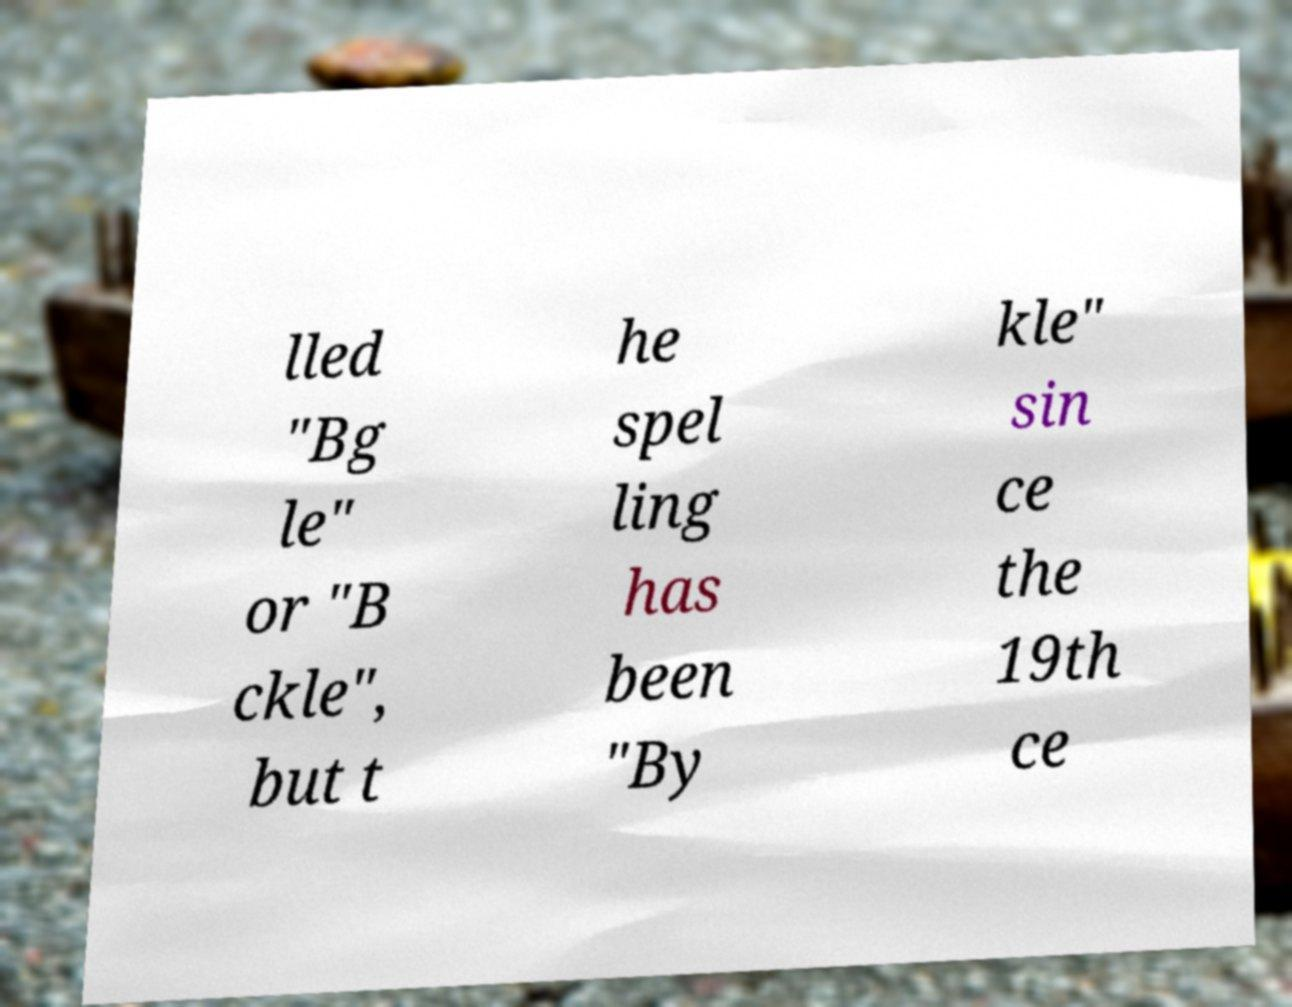I need the written content from this picture converted into text. Can you do that? lled "Bg le" or "B ckle", but t he spel ling has been "By kle" sin ce the 19th ce 